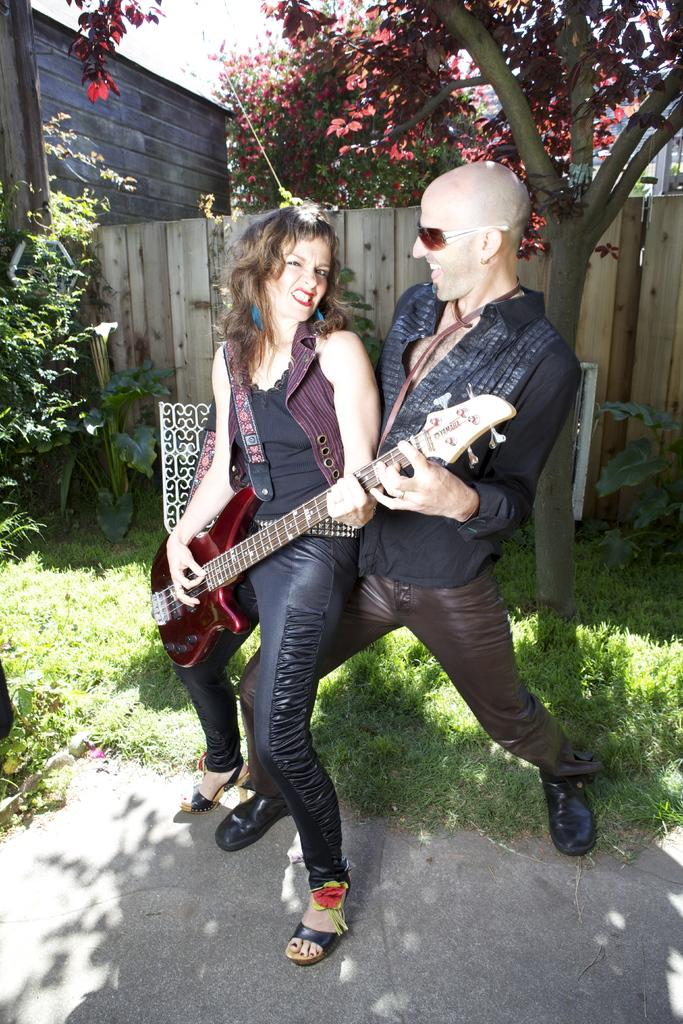How many people are in the image? There are two persons in the image. What is one of the persons doing in the image? One of the persons is playing a guitar. What can be seen in the background of the image? There are trees and green grass in the background of the image. Where is the faucet located in the image? There is no faucet present in the image. What kind of trouble are the two persons experiencing in the image? There is no indication of trouble in the image; the two persons are simply present and one is playing a guitar. 